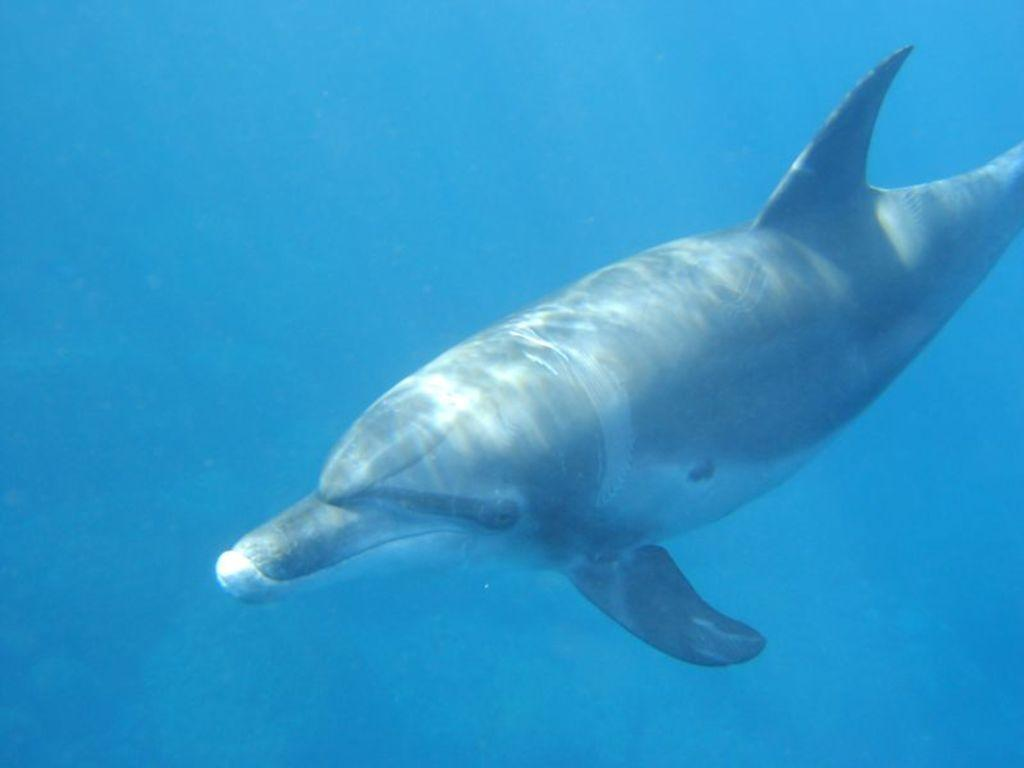What animal is present in the image? There is a dolphin in the image. Where is the dolphin located? The dolphin is in the water. What is the color of the water in the image? The water appears blue in color. What type of toys can be seen floating in the water with the dolphin? There are no toys present in the image; it only features a dolphin in the water. 